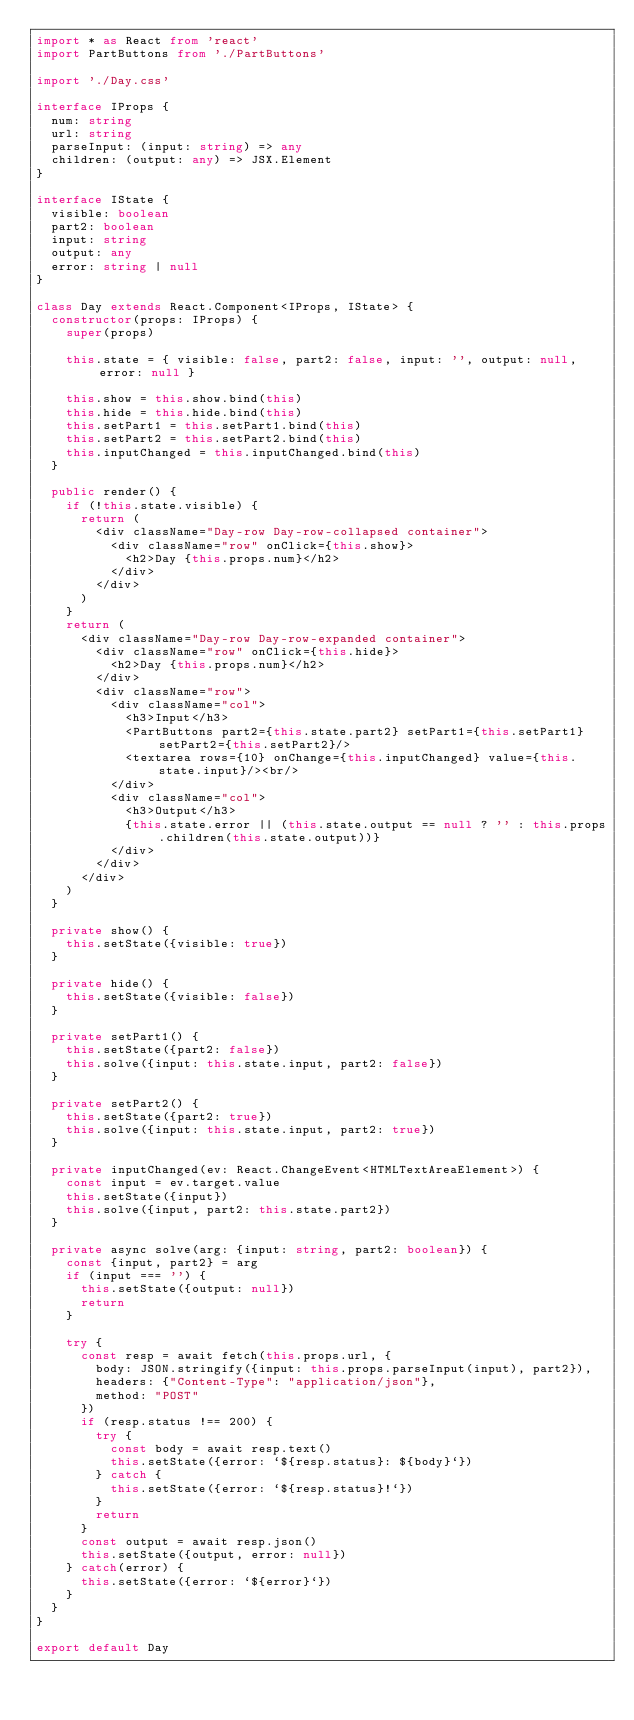<code> <loc_0><loc_0><loc_500><loc_500><_TypeScript_>import * as React from 'react'
import PartButtons from './PartButtons'

import './Day.css'

interface IProps {
  num: string
  url: string
  parseInput: (input: string) => any
  children: (output: any) => JSX.Element
}

interface IState {
  visible: boolean
  part2: boolean
  input: string
  output: any
  error: string | null
}

class Day extends React.Component<IProps, IState> {
  constructor(props: IProps) {
    super(props)

    this.state = { visible: false, part2: false, input: '', output: null, error: null }

    this.show = this.show.bind(this)
    this.hide = this.hide.bind(this)
    this.setPart1 = this.setPart1.bind(this)
    this.setPart2 = this.setPart2.bind(this)
    this.inputChanged = this.inputChanged.bind(this)
  }

  public render() {
    if (!this.state.visible) {
      return (
        <div className="Day-row Day-row-collapsed container">
          <div className="row" onClick={this.show}>
            <h2>Day {this.props.num}</h2>
          </div>
        </div>
      )
    }
    return (
      <div className="Day-row Day-row-expanded container">
        <div className="row" onClick={this.hide}>
          <h2>Day {this.props.num}</h2>
        </div>
        <div className="row">
          <div className="col">
            <h3>Input</h3>
            <PartButtons part2={this.state.part2} setPart1={this.setPart1} setPart2={this.setPart2}/>
            <textarea rows={10} onChange={this.inputChanged} value={this.state.input}/><br/>
          </div>
          <div className="col">
            <h3>Output</h3>
            {this.state.error || (this.state.output == null ? '' : this.props.children(this.state.output))}
          </div>
        </div>
      </div>
    )
  }

  private show() {
    this.setState({visible: true})
  }

  private hide() {
    this.setState({visible: false})
  }

  private setPart1() {
    this.setState({part2: false})
    this.solve({input: this.state.input, part2: false})
  }

  private setPart2() {
    this.setState({part2: true})
    this.solve({input: this.state.input, part2: true})
  }

  private inputChanged(ev: React.ChangeEvent<HTMLTextAreaElement>) {
    const input = ev.target.value
    this.setState({input})
    this.solve({input, part2: this.state.part2})
  }

  private async solve(arg: {input: string, part2: boolean}) {
    const {input, part2} = arg
    if (input === '') {
      this.setState({output: null})
      return
    }

    try {
      const resp = await fetch(this.props.url, {
        body: JSON.stringify({input: this.props.parseInput(input), part2}),
        headers: {"Content-Type": "application/json"},
        method: "POST"
      })
      if (resp.status !== 200) {
        try {
          const body = await resp.text()
          this.setState({error: `${resp.status}: ${body}`})
        } catch {
          this.setState({error: `${resp.status}!`})
        }
        return
      }
      const output = await resp.json()
      this.setState({output, error: null})
    } catch(error) {
      this.setState({error: `${error}`})
    }
  }
}

export default Day
</code> 